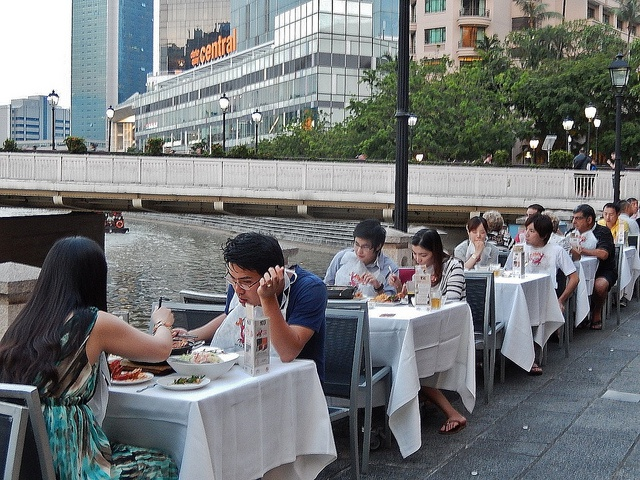Describe the objects in this image and their specific colors. I can see people in white, black, gray, teal, and brown tones, dining table in white, darkgray, gray, and black tones, chair in white, black, gray, and darkgray tones, dining table in white, darkgray, lightgray, gray, and brown tones, and people in white, black, navy, brown, and maroon tones in this image. 